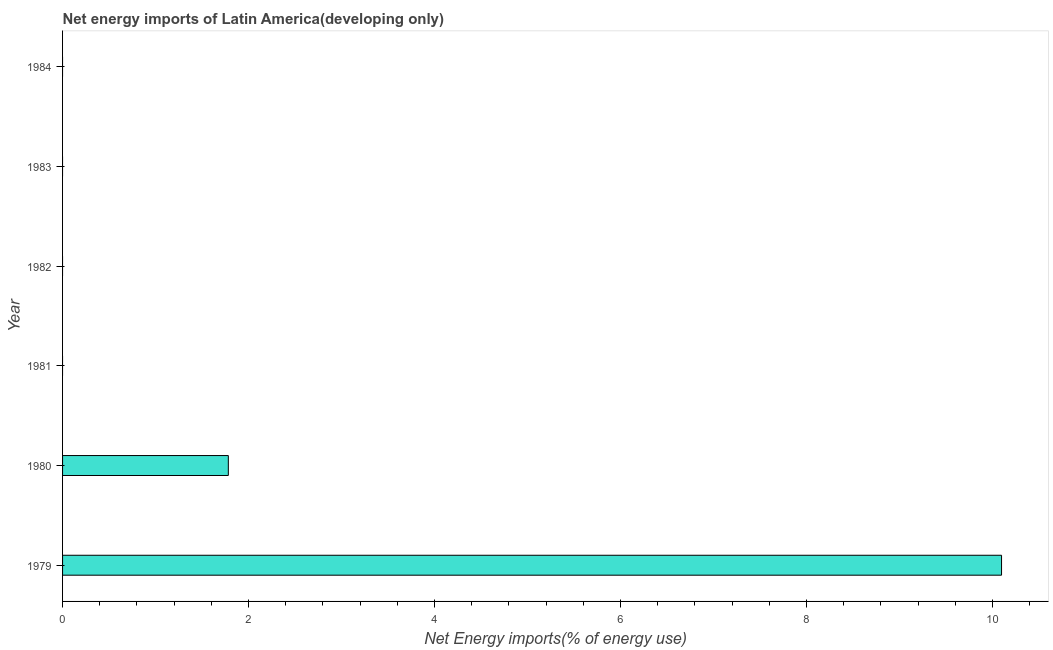Does the graph contain grids?
Provide a short and direct response. No. What is the title of the graph?
Give a very brief answer. Net energy imports of Latin America(developing only). What is the label or title of the X-axis?
Offer a very short reply. Net Energy imports(% of energy use). What is the label or title of the Y-axis?
Keep it short and to the point. Year. What is the energy imports in 1980?
Your answer should be very brief. 1.78. Across all years, what is the maximum energy imports?
Provide a short and direct response. 10.1. Across all years, what is the minimum energy imports?
Make the answer very short. 0. In which year was the energy imports maximum?
Provide a short and direct response. 1979. What is the sum of the energy imports?
Offer a terse response. 11.88. What is the difference between the energy imports in 1979 and 1980?
Offer a terse response. 8.32. What is the average energy imports per year?
Provide a succinct answer. 1.98. What is the median energy imports?
Your answer should be compact. 0. What is the ratio of the energy imports in 1979 to that in 1980?
Give a very brief answer. 5.67. What is the difference between the highest and the lowest energy imports?
Your answer should be compact. 10.1. In how many years, is the energy imports greater than the average energy imports taken over all years?
Offer a terse response. 1. Are all the bars in the graph horizontal?
Offer a very short reply. Yes. How many years are there in the graph?
Keep it short and to the point. 6. Are the values on the major ticks of X-axis written in scientific E-notation?
Your answer should be very brief. No. What is the Net Energy imports(% of energy use) in 1979?
Give a very brief answer. 10.1. What is the Net Energy imports(% of energy use) in 1980?
Ensure brevity in your answer.  1.78. What is the difference between the Net Energy imports(% of energy use) in 1979 and 1980?
Make the answer very short. 8.32. What is the ratio of the Net Energy imports(% of energy use) in 1979 to that in 1980?
Your response must be concise. 5.67. 